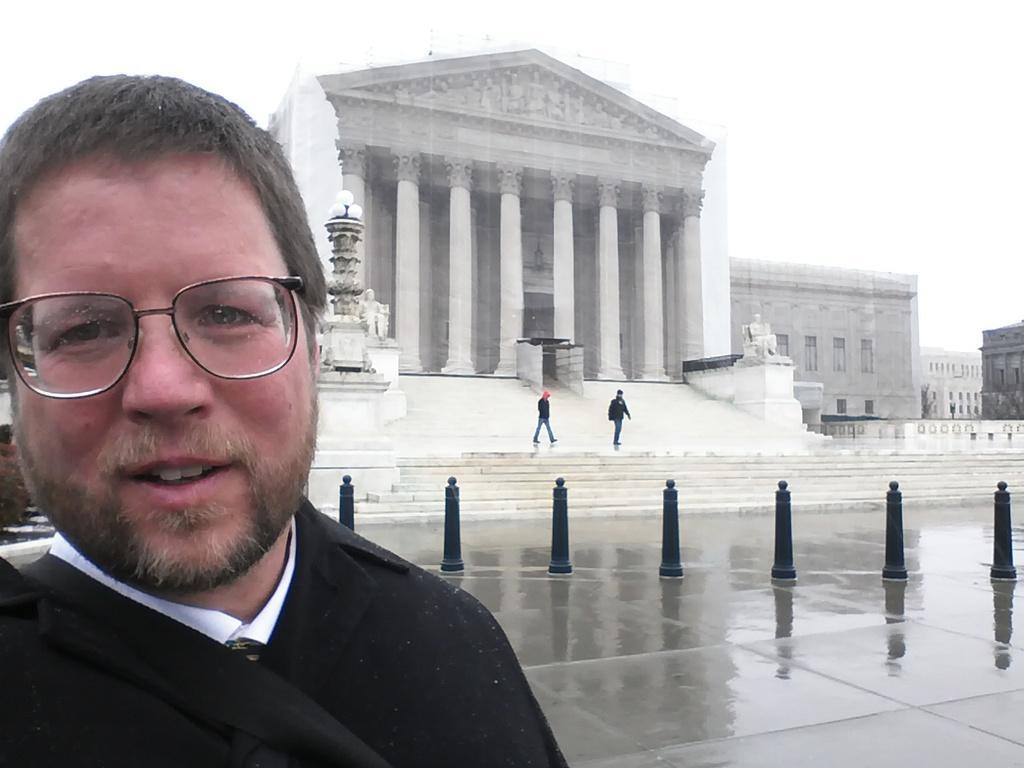Could you give a brief overview of what you see in this image? In this image we can see a person standing on the road, barrier poles, persons standing on the staircase, street lights, statues, buildings and sky. 